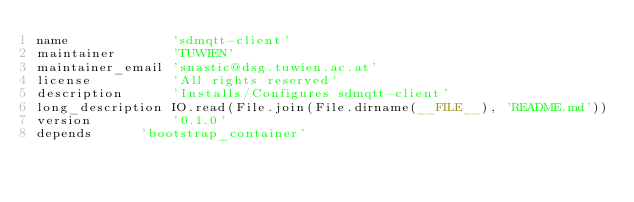<code> <loc_0><loc_0><loc_500><loc_500><_Ruby_>name             'sdmqtt-client'
maintainer       'TUWIEN'
maintainer_email 'snastic@dsg.tuwien.ac.at'
license          'All rights reserved'
description      'Installs/Configures sdmqtt-client'
long_description IO.read(File.join(File.dirname(__FILE__), 'README.md'))
version          '0.1.0'
depends			 'bootstrap_container'</code> 